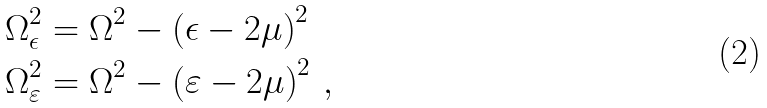<formula> <loc_0><loc_0><loc_500><loc_500>\Omega _ { \epsilon } ^ { 2 } & = \Omega ^ { 2 } - \left ( \epsilon - 2 \mu \right ) ^ { 2 } \\ \Omega _ { \varepsilon } ^ { 2 } & = \Omega ^ { 2 } - \left ( \varepsilon - 2 \mu \right ) ^ { 2 } \, ,</formula> 